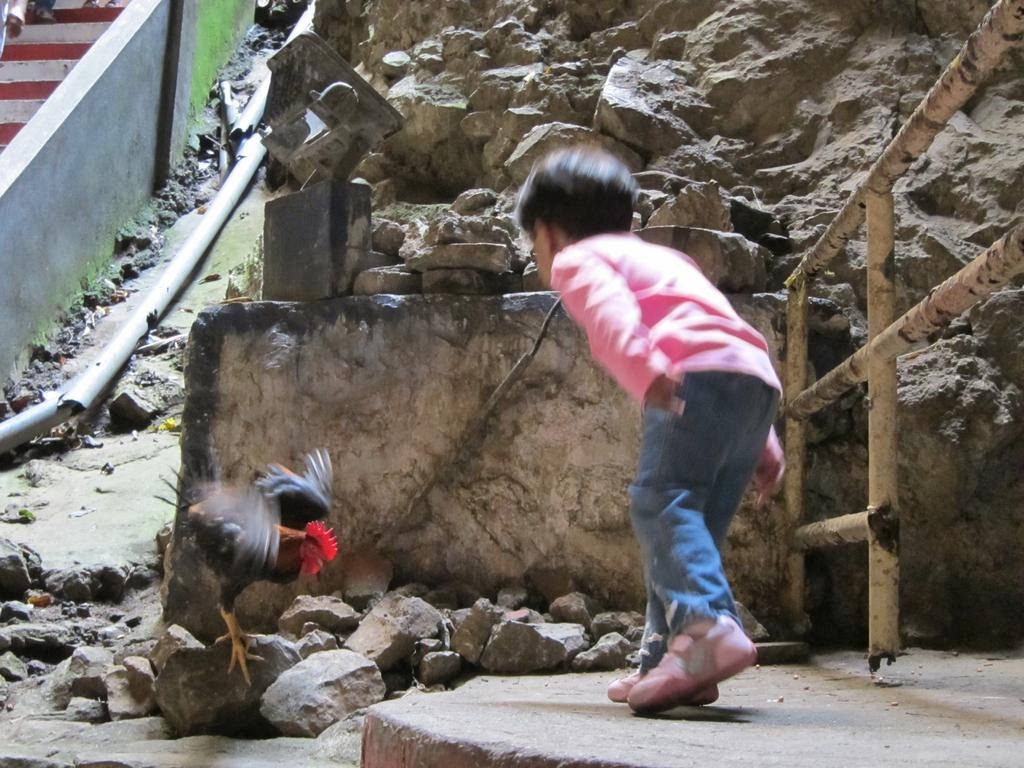What is the main subject of the image? There is a person in the image. What colors is the person wearing? The person is wearing black and brown colors. What other living creatures are present in the image? There are birds in the image. What colors are the birds wearing? The birds are wearing black and brown colors. What natural element can be seen in the image? There is a rock in the image. What man-made objects are present in the image? There is a pipe, a wall, and a railing in the image. Can you tell me how many buttons the bear is wearing in the image? There is no bear present in the image, and therefore no buttons to count. What type of guide is assisting the person in the image? There is no guide present in the image, and the person is not interacting with anyone else. 